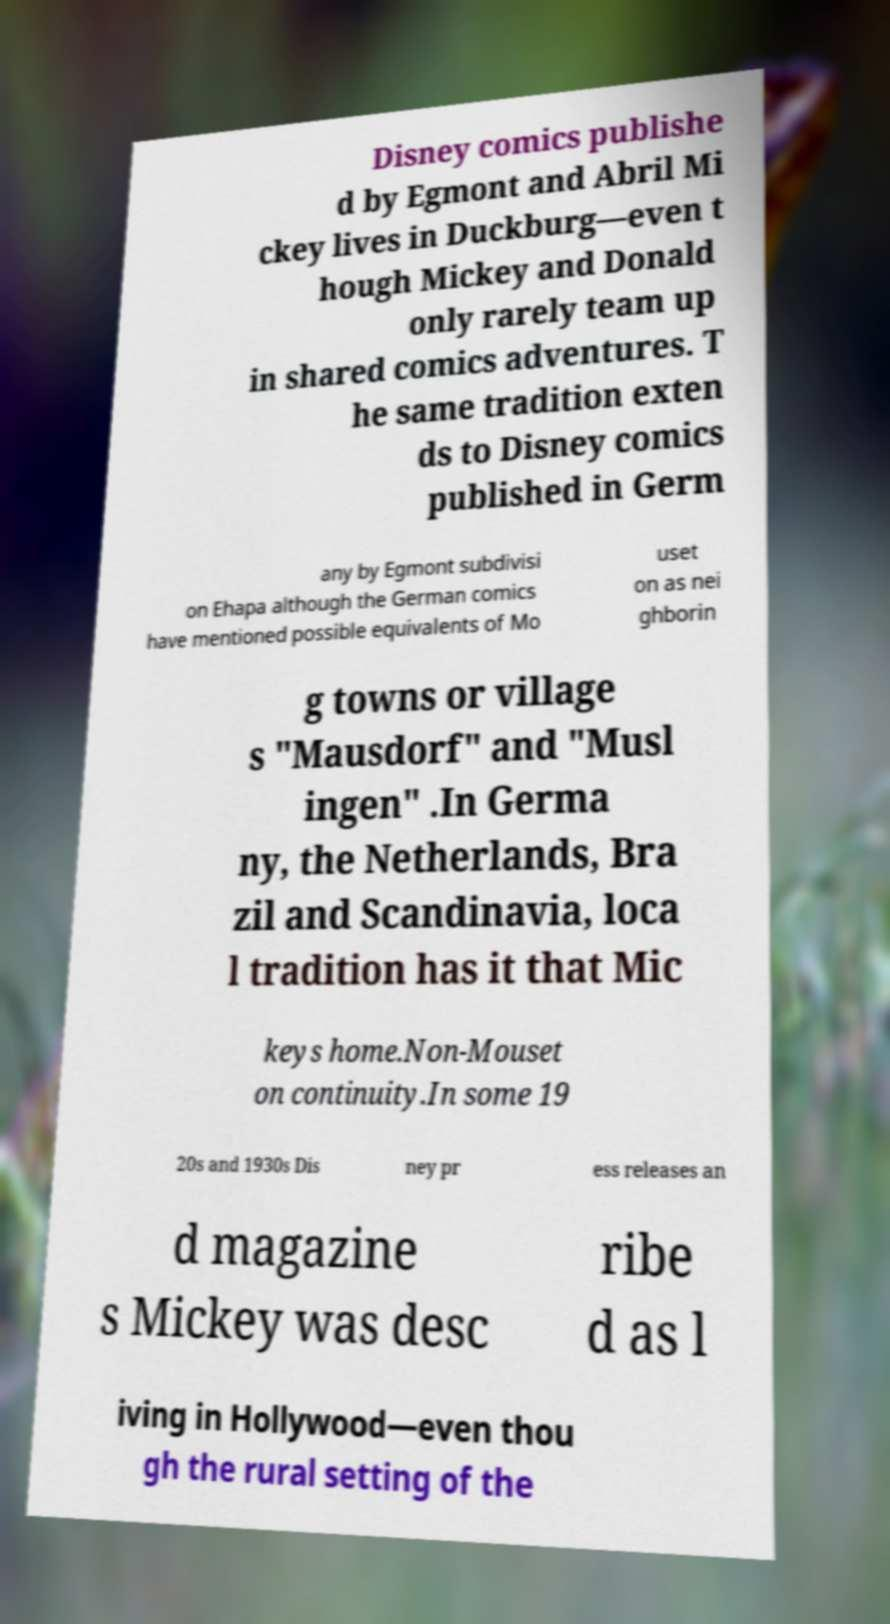There's text embedded in this image that I need extracted. Can you transcribe it verbatim? Disney comics publishe d by Egmont and Abril Mi ckey lives in Duckburg—even t hough Mickey and Donald only rarely team up in shared comics adventures. T he same tradition exten ds to Disney comics published in Germ any by Egmont subdivisi on Ehapa although the German comics have mentioned possible equivalents of Mo uset on as nei ghborin g towns or village s "Mausdorf" and "Musl ingen" .In Germa ny, the Netherlands, Bra zil and Scandinavia, loca l tradition has it that Mic keys home.Non-Mouset on continuity.In some 19 20s and 1930s Dis ney pr ess releases an d magazine s Mickey was desc ribe d as l iving in Hollywood—even thou gh the rural setting of the 